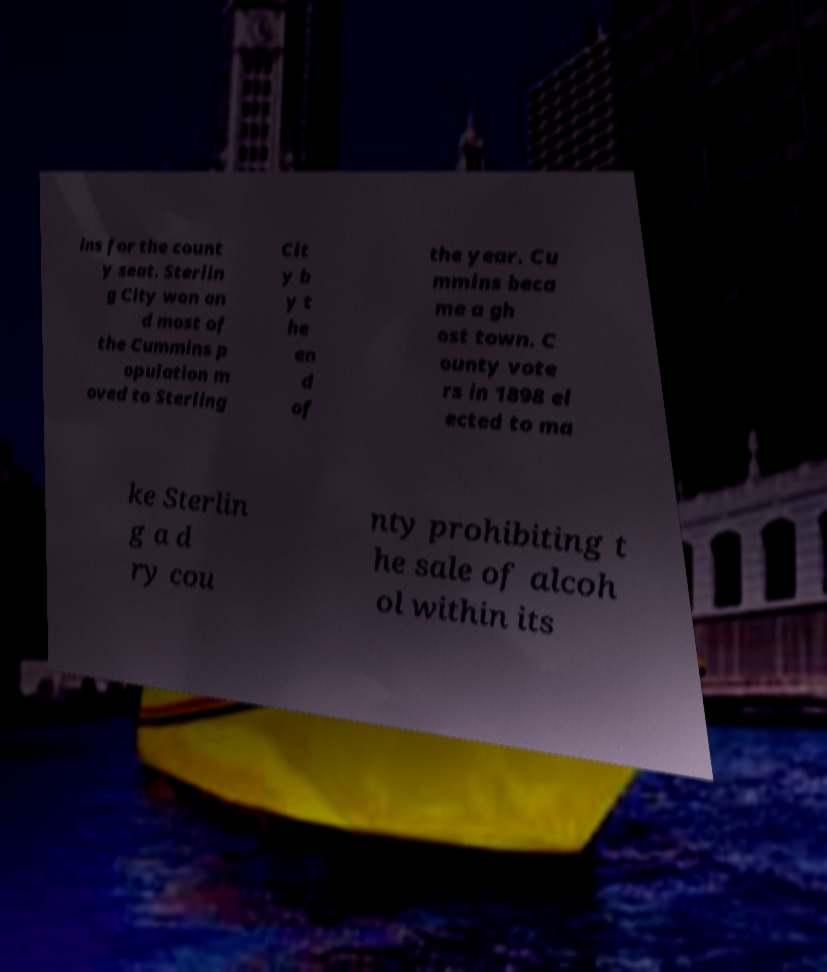What messages or text are displayed in this image? I need them in a readable, typed format. ins for the count y seat. Sterlin g City won an d most of the Cummins p opulation m oved to Sterling Cit y b y t he en d of the year. Cu mmins beca me a gh ost town. C ounty vote rs in 1898 el ected to ma ke Sterlin g a d ry cou nty prohibiting t he sale of alcoh ol within its 